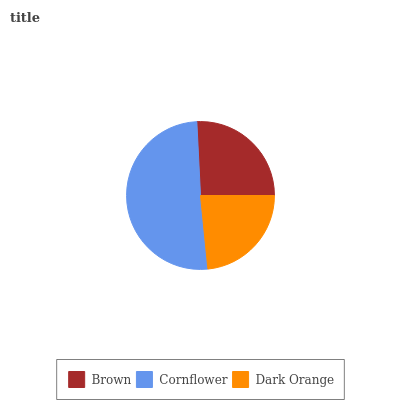Is Dark Orange the minimum?
Answer yes or no. Yes. Is Cornflower the maximum?
Answer yes or no. Yes. Is Cornflower the minimum?
Answer yes or no. No. Is Dark Orange the maximum?
Answer yes or no. No. Is Cornflower greater than Dark Orange?
Answer yes or no. Yes. Is Dark Orange less than Cornflower?
Answer yes or no. Yes. Is Dark Orange greater than Cornflower?
Answer yes or no. No. Is Cornflower less than Dark Orange?
Answer yes or no. No. Is Brown the high median?
Answer yes or no. Yes. Is Brown the low median?
Answer yes or no. Yes. Is Dark Orange the high median?
Answer yes or no. No. Is Dark Orange the low median?
Answer yes or no. No. 